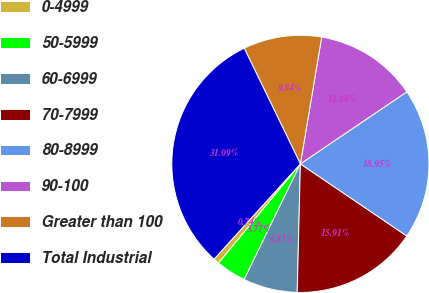Convert chart to OTSL. <chart><loc_0><loc_0><loc_500><loc_500><pie_chart><fcel>0-4999<fcel>50-5999<fcel>60-6999<fcel>70-7999<fcel>80-8999<fcel>90-100<fcel>Greater than 100<fcel>Total Industrial<nl><fcel>0.74%<fcel>3.77%<fcel>6.81%<fcel>15.91%<fcel>18.95%<fcel>12.88%<fcel>9.84%<fcel>31.09%<nl></chart> 